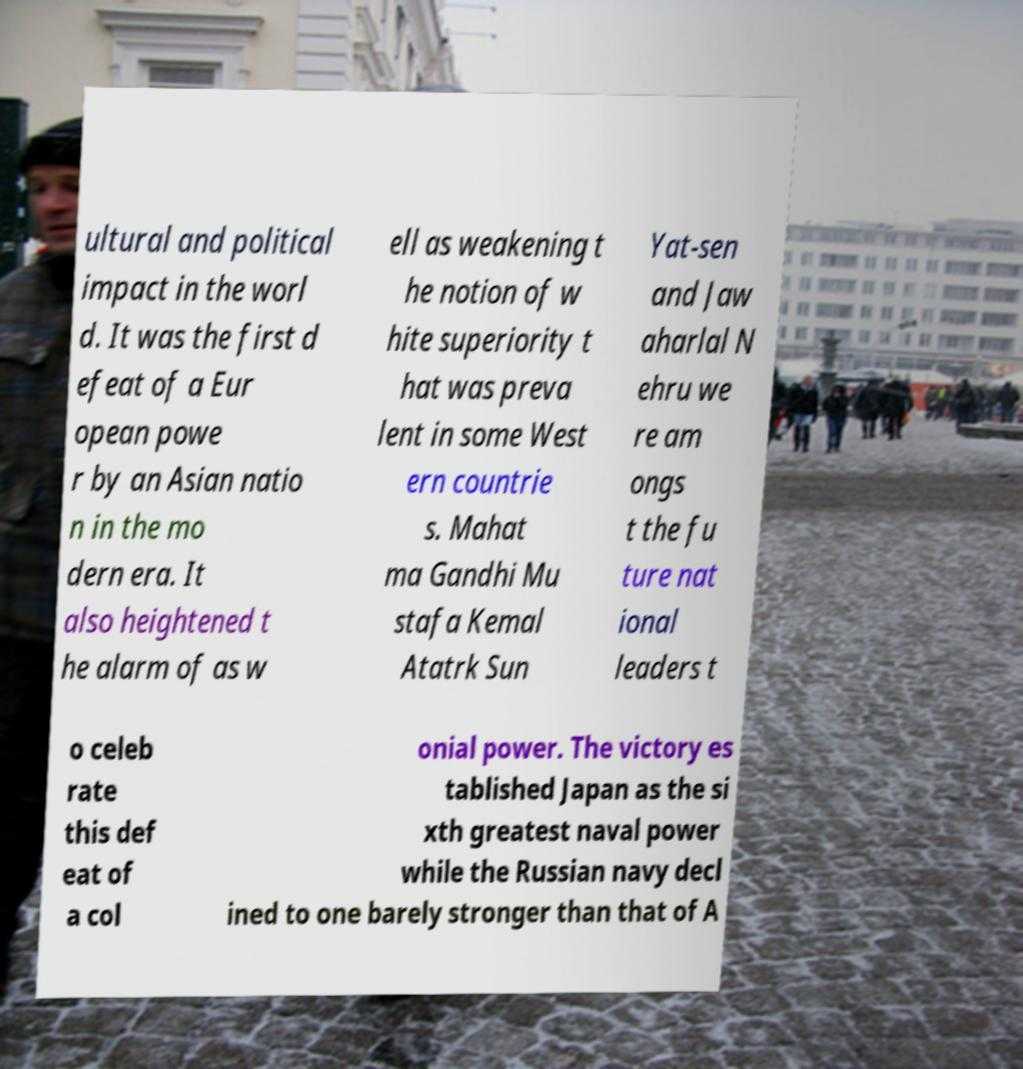Could you assist in decoding the text presented in this image and type it out clearly? ultural and political impact in the worl d. It was the first d efeat of a Eur opean powe r by an Asian natio n in the mo dern era. It also heightened t he alarm of as w ell as weakening t he notion of w hite superiority t hat was preva lent in some West ern countrie s. Mahat ma Gandhi Mu stafa Kemal Atatrk Sun Yat-sen and Jaw aharlal N ehru we re am ongs t the fu ture nat ional leaders t o celeb rate this def eat of a col onial power. The victory es tablished Japan as the si xth greatest naval power while the Russian navy decl ined to one barely stronger than that of A 